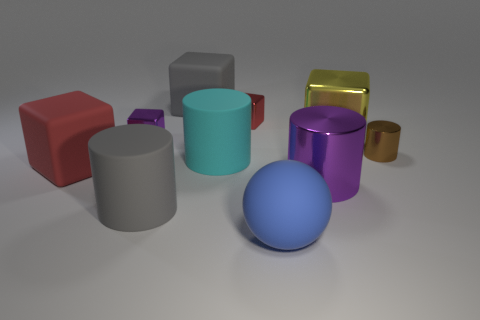Subtract all purple metallic cylinders. How many cylinders are left? 3 Subtract all spheres. How many objects are left? 9 Subtract 5 cubes. How many cubes are left? 0 Add 4 big blue matte cylinders. How many big blue matte cylinders exist? 4 Subtract all cyan cylinders. How many cylinders are left? 3 Subtract 0 yellow cylinders. How many objects are left? 10 Subtract all green blocks. Subtract all yellow balls. How many blocks are left? 5 Subtract all green spheres. How many red blocks are left? 2 Subtract all large matte objects. Subtract all brown cylinders. How many objects are left? 4 Add 1 tiny purple cubes. How many tiny purple cubes are left? 2 